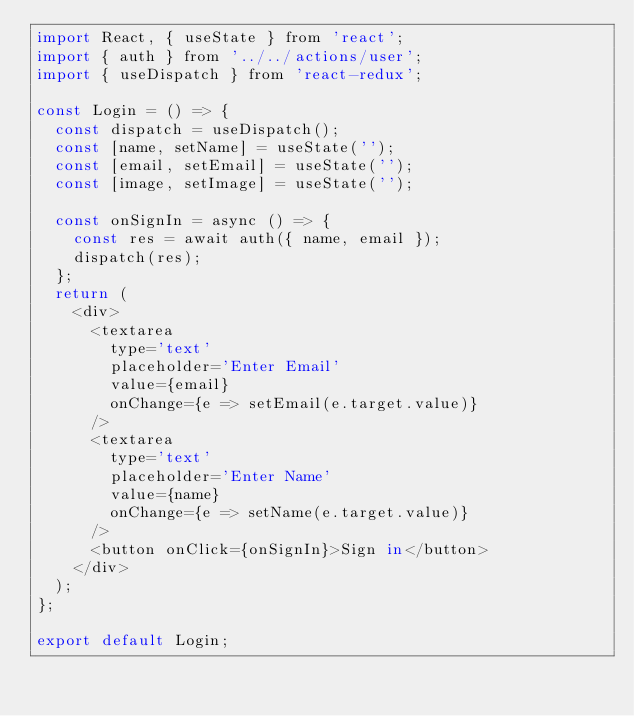Convert code to text. <code><loc_0><loc_0><loc_500><loc_500><_JavaScript_>import React, { useState } from 'react';
import { auth } from '../../actions/user';
import { useDispatch } from 'react-redux';

const Login = () => {
  const dispatch = useDispatch();
  const [name, setName] = useState('');
  const [email, setEmail] = useState('');
  const [image, setImage] = useState('');

  const onSignIn = async () => {
    const res = await auth({ name, email });
    dispatch(res);
  };
  return (
    <div>
      <textarea
        type='text'
        placeholder='Enter Email'
        value={email}
        onChange={e => setEmail(e.target.value)}
      />
      <textarea
        type='text'
        placeholder='Enter Name'
        value={name}
        onChange={e => setName(e.target.value)}
      />
      <button onClick={onSignIn}>Sign in</button>
    </div>
  );
};

export default Login;
</code> 